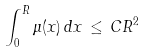<formula> <loc_0><loc_0><loc_500><loc_500>\int _ { 0 } ^ { R } \mu ( x ) \, d x \, \leq \, C R ^ { 2 }</formula> 